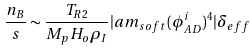<formula> <loc_0><loc_0><loc_500><loc_500>\frac { n _ { B } } { s } \sim \frac { T _ { R 2 } } { M _ { p } H _ { o } \rho _ { I } } | a m _ { s o f t } ( \phi _ { A D } ^ { i } ) ^ { 4 } | \delta _ { e f f }</formula> 